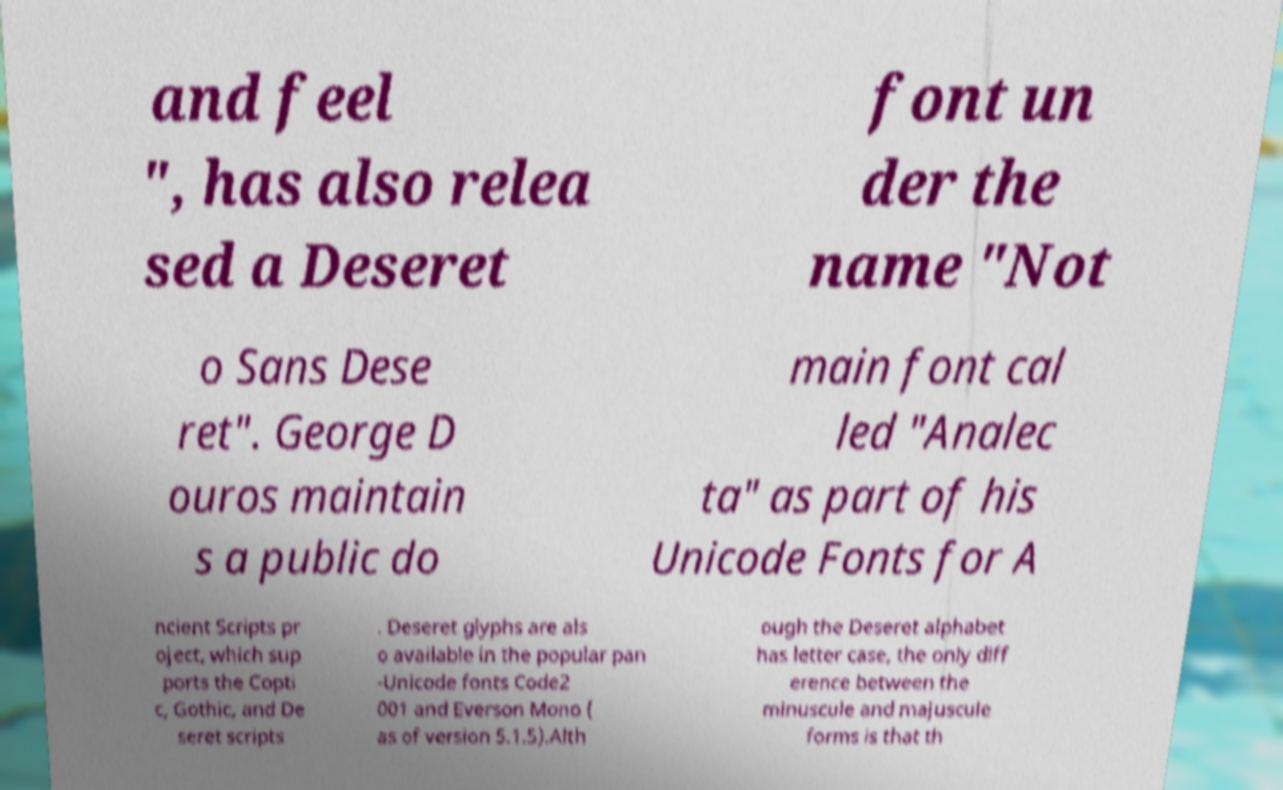What messages or text are displayed in this image? I need them in a readable, typed format. and feel ", has also relea sed a Deseret font un der the name "Not o Sans Dese ret". George D ouros maintain s a public do main font cal led "Analec ta" as part of his Unicode Fonts for A ncient Scripts pr oject, which sup ports the Copti c, Gothic, and De seret scripts . Deseret glyphs are als o available in the popular pan -Unicode fonts Code2 001 and Everson Mono ( as of version 5.1.5).Alth ough the Deseret alphabet has letter case, the only diff erence between the minuscule and majuscule forms is that th 